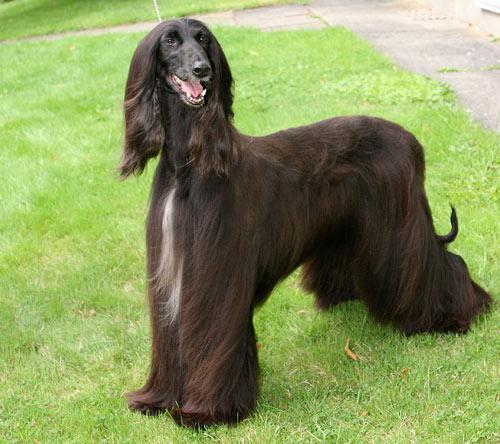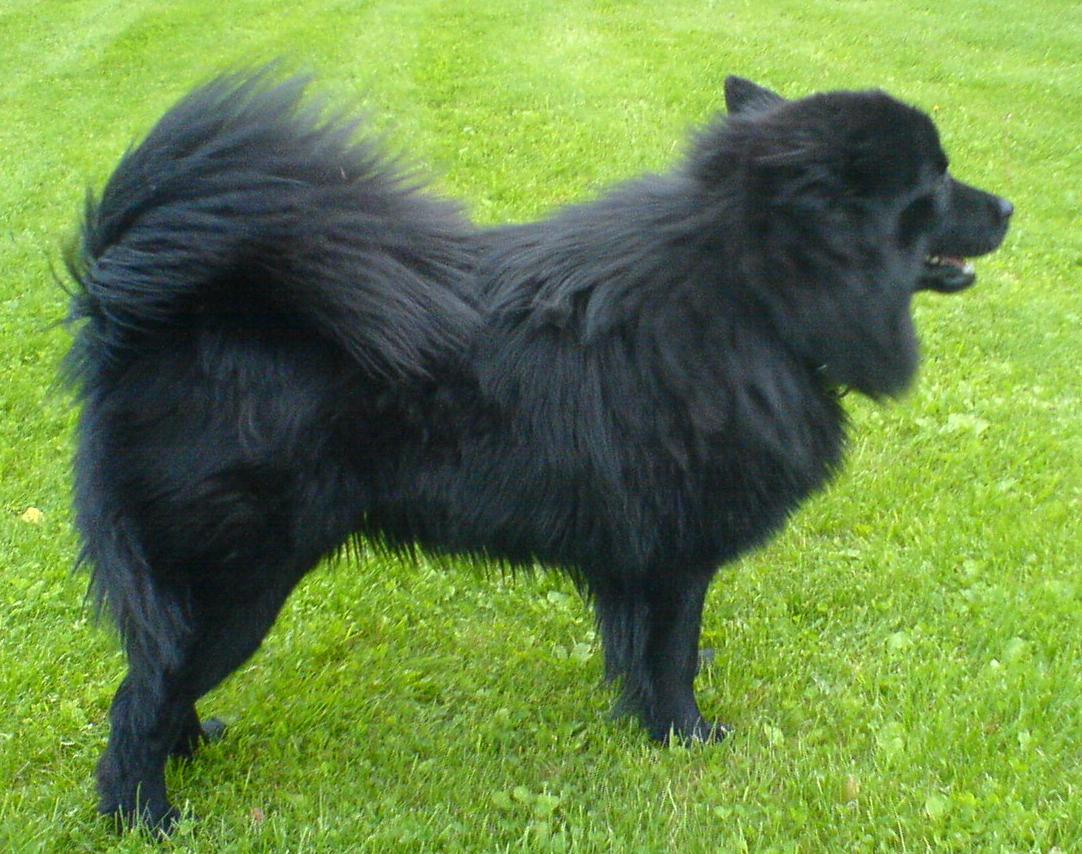The first image is the image on the left, the second image is the image on the right. Considering the images on both sides, is "The left and right image contains the same number of dogs facing opposite directions." valid? Answer yes or no. Yes. The first image is the image on the left, the second image is the image on the right. Considering the images on both sides, is "The dogs are oriented in opposite directions." valid? Answer yes or no. Yes. 